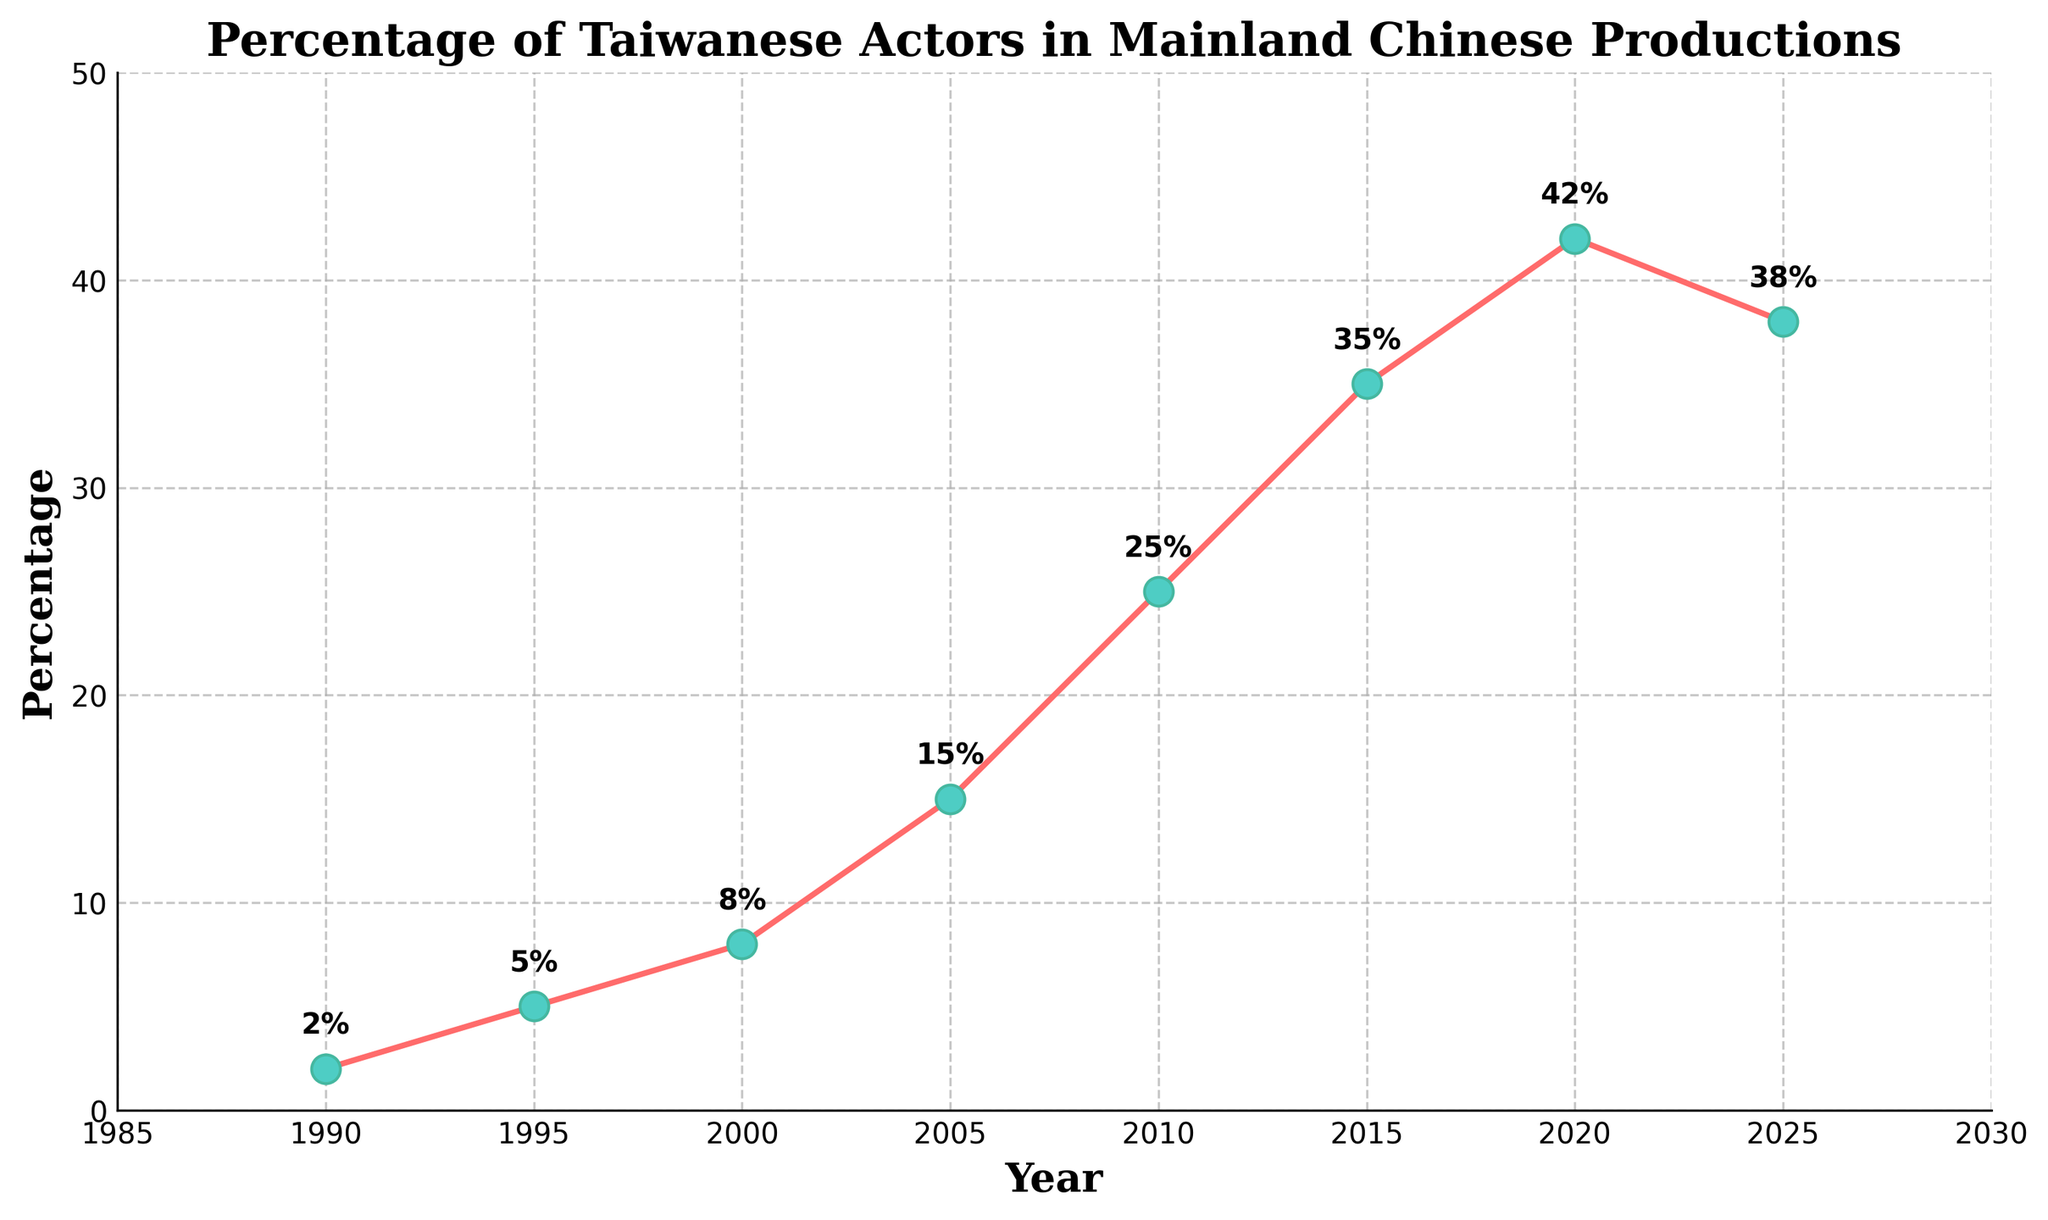What year saw the highest percentage of Taiwanese actors in mainland Chinese productions? According to the figure, the highest percentage is around 2020 at 42%.
Answer: 2020 By how much did the percentage increase between 1990 and 2020? The percentage in 1990 is 2%, and in 2020 it is 42%. The increase is calculated as 42% - 2% = 40%.
Answer: 40% Which period experienced the most significant growth in percentage? By looking at the steepness of the line, the period between 2005 and 2010 shows the most significant growth, increasing from 15% to 25%.
Answer: 2005 to 2010 What is the average percentage of Taiwanese actors working in mainland Chinese productions over the three decades? Sum the percentages for each year and divide by the number of data points: (2 + 5 + 8 + 15 + 25 + 35 + 42 + 38) / 8 = 21.25%.
Answer: 21.25% Was there any period where the percentage decreased? From the figure, the percentage decreases from 42% in 2020 to 38% in 2025.
Answer: Yes What color is used for the markers on the line plot? The figure shows markers in a greenish-blue color.
Answer: Greenish-blue How much did the percentage change from 2000 to 2015? In 2000, it was 8%, and in 2015, it was 35%. The change is 35% - 8% = 27%.
Answer: 27% What percentage does the line reach by 2025? According to the annotation on the plot for 2025, it reaches 38%.
Answer: 38% Between which successive years is the smallest increase in percentage observed? The smallest increase is observed between 2015 (35%) and 2020 (42%), which is an increase of 7%.
Answer: 2015 to 2020 What is the total increase in percentage from 1990 to 2025? The percentage starts at 2% in 1990 and ends at 38% in 2025, giving an increase of 38% - 2% = 36%.
Answer: 36% 